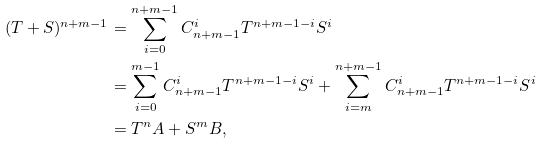<formula> <loc_0><loc_0><loc_500><loc_500>( T + S ) ^ { n + m - 1 } & = \sum _ { i = 0 } ^ { n + m - 1 } C _ { n + m - 1 } ^ { i } T ^ { n + m - 1 - i } S ^ { i } \\ & = \sum _ { i = 0 } ^ { m - 1 } C _ { n + m - 1 } ^ { i } T ^ { n + m - 1 - i } S ^ { i } + \sum _ { i = m } ^ { n + m - 1 } C _ { n + m - 1 } ^ { i } T ^ { n + m - 1 - i } S ^ { i } \\ & = T ^ { n } A + S ^ { m } B ,</formula> 